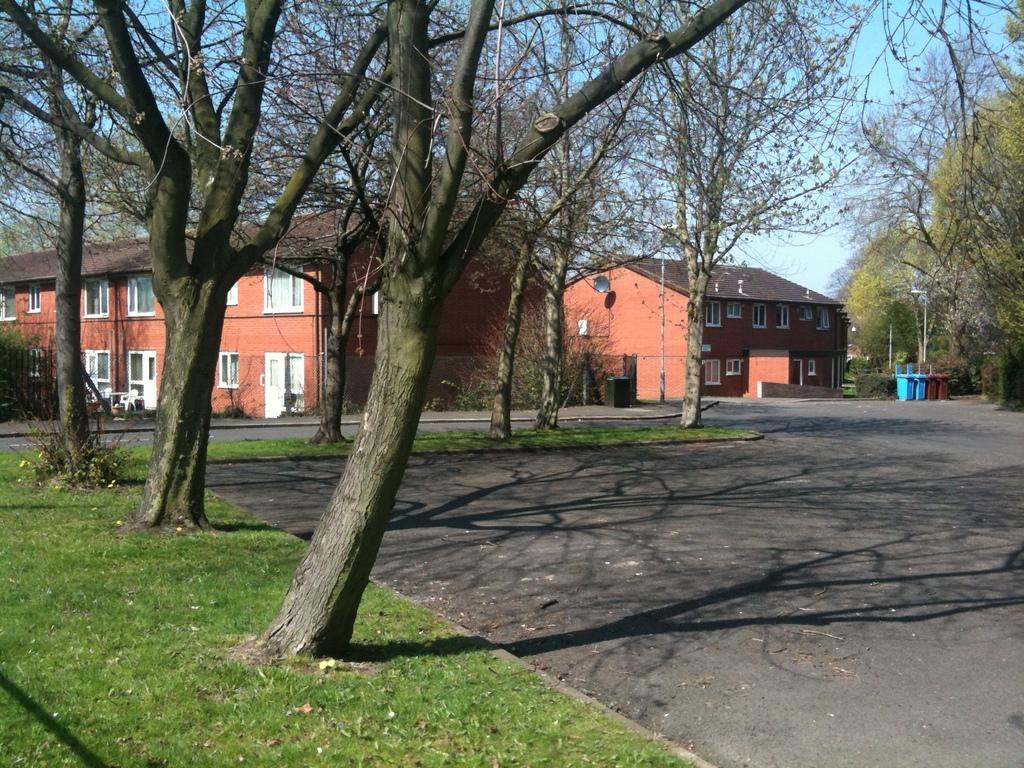What type of structures can be seen in the image? There are buildings in the image. What is located in front of the buildings? Trees and grass are visible in front of the buildings. Where are the dustbins located in the image? The dustbins are on the right side of the image. What else is present on the right side of the image? Trees are also on the right side of the image. What is visible at the top of the image? The sky is visible at the top of the image. What type of brass instrument can be seen being played in the middle of the image? There is no brass instrument or any musical activity present in the image. 